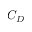<formula> <loc_0><loc_0><loc_500><loc_500>C _ { D }</formula> 